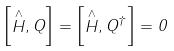Convert formula to latex. <formula><loc_0><loc_0><loc_500><loc_500>\left [ \stackrel { \wedge } { H } , Q \right ] = \left [ \stackrel { \wedge } { H } , Q ^ { \dagger } \right ] = 0</formula> 